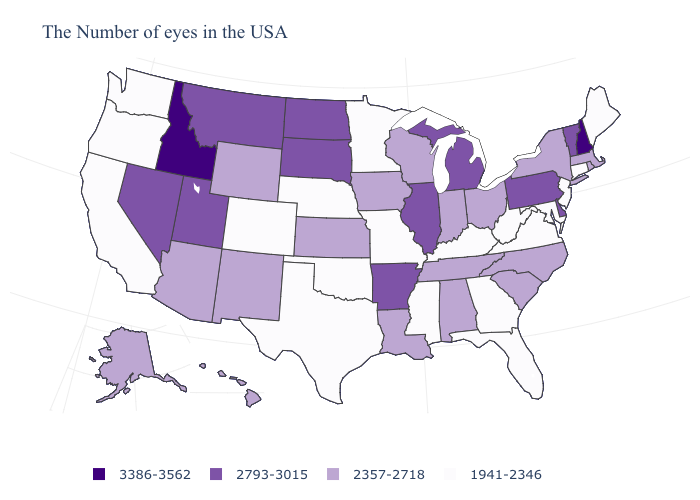What is the highest value in the USA?
Answer briefly. 3386-3562. What is the highest value in the USA?
Concise answer only. 3386-3562. What is the value of Ohio?
Concise answer only. 2357-2718. Does Nevada have the highest value in the USA?
Quick response, please. No. Does the map have missing data?
Quick response, please. No. Does the map have missing data?
Quick response, please. No. Name the states that have a value in the range 2793-3015?
Concise answer only. Vermont, Delaware, Pennsylvania, Michigan, Illinois, Arkansas, South Dakota, North Dakota, Utah, Montana, Nevada. What is the value of Delaware?
Short answer required. 2793-3015. What is the value of Wisconsin?
Be succinct. 2357-2718. What is the value of Montana?
Be succinct. 2793-3015. Which states hav the highest value in the Northeast?
Concise answer only. New Hampshire. What is the value of Nebraska?
Quick response, please. 1941-2346. Which states have the highest value in the USA?
Write a very short answer. New Hampshire, Idaho. Does Arkansas have a lower value than Idaho?
Quick response, please. Yes. 